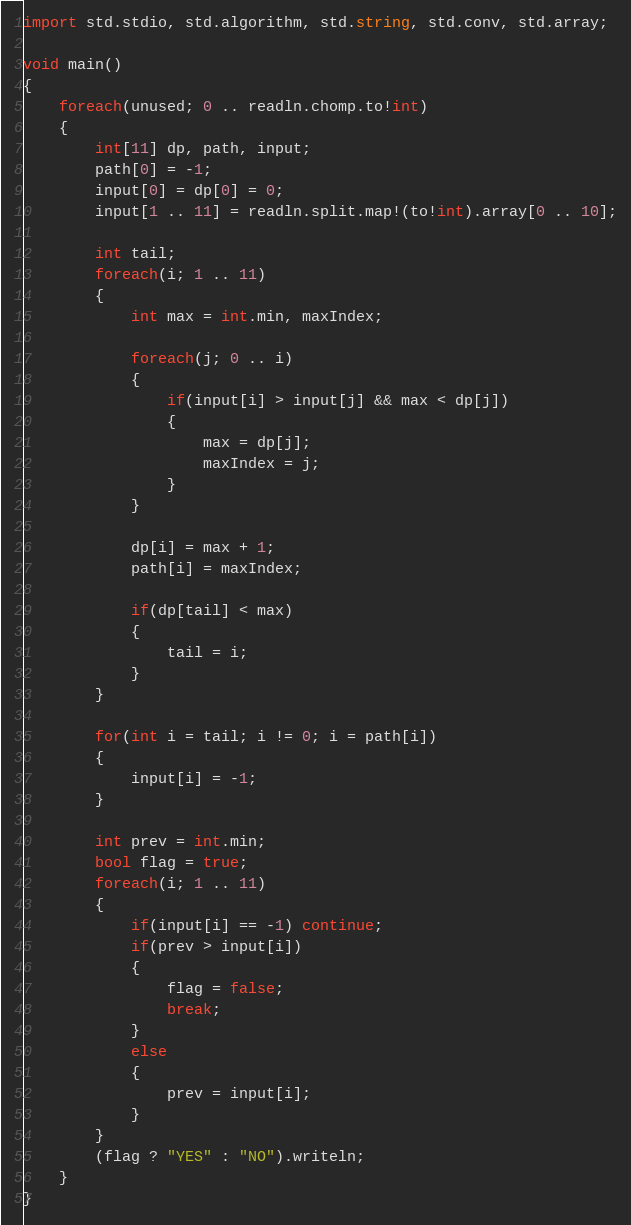<code> <loc_0><loc_0><loc_500><loc_500><_D_>import std.stdio, std.algorithm, std.string, std.conv, std.array;

void main()
{
    foreach(unused; 0 .. readln.chomp.to!int)
    {
        int[11] dp, path, input;
        path[0] = -1;
        input[0] = dp[0] = 0;
        input[1 .. 11] = readln.split.map!(to!int).array[0 .. 10];

        int tail;
        foreach(i; 1 .. 11)
        {
            int max = int.min, maxIndex;

            foreach(j; 0 .. i)
            {
                if(input[i] > input[j] && max < dp[j])
                {
                    max = dp[j];
                    maxIndex = j;
                }
            }

            dp[i] = max + 1;
            path[i] = maxIndex;

            if(dp[tail] < max)
            {
                tail = i;
            }
        }

        for(int i = tail; i != 0; i = path[i])
        {
            input[i] = -1;
        }

        int prev = int.min;
        bool flag = true;
        foreach(i; 1 .. 11)
        {
            if(input[i] == -1) continue;
            if(prev > input[i])
            {
                flag = false;
                break;
            }
            else
            {
                prev = input[i];
            }
        }
        (flag ? "YES" : "NO").writeln;
    }
}</code> 